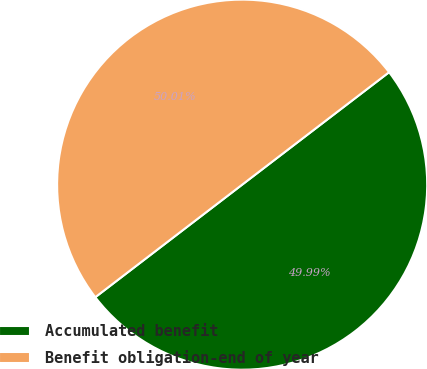Convert chart to OTSL. <chart><loc_0><loc_0><loc_500><loc_500><pie_chart><fcel>Accumulated benefit<fcel>Benefit obligation-end of year<nl><fcel>49.99%<fcel>50.01%<nl></chart> 